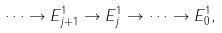Convert formula to latex. <formula><loc_0><loc_0><loc_500><loc_500>\dots \rightarrow E ^ { 1 } _ { j + 1 } \rightarrow E ^ { 1 } _ { j } \rightarrow \dots \rightarrow E ^ { 1 } _ { 0 } ,</formula> 